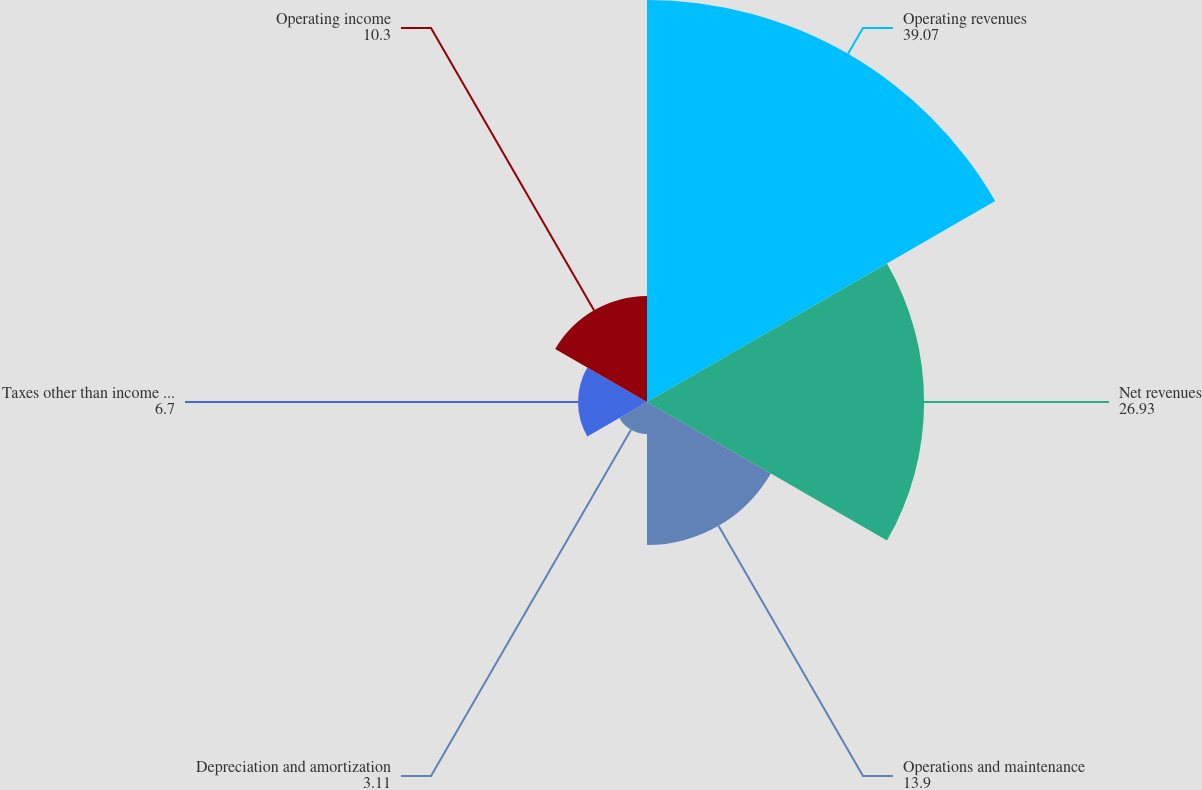Convert chart to OTSL. <chart><loc_0><loc_0><loc_500><loc_500><pie_chart><fcel>Operating revenues<fcel>Net revenues<fcel>Operations and maintenance<fcel>Depreciation and amortization<fcel>Taxes other than income taxes<fcel>Operating income<nl><fcel>39.07%<fcel>26.93%<fcel>13.9%<fcel>3.11%<fcel>6.7%<fcel>10.3%<nl></chart> 